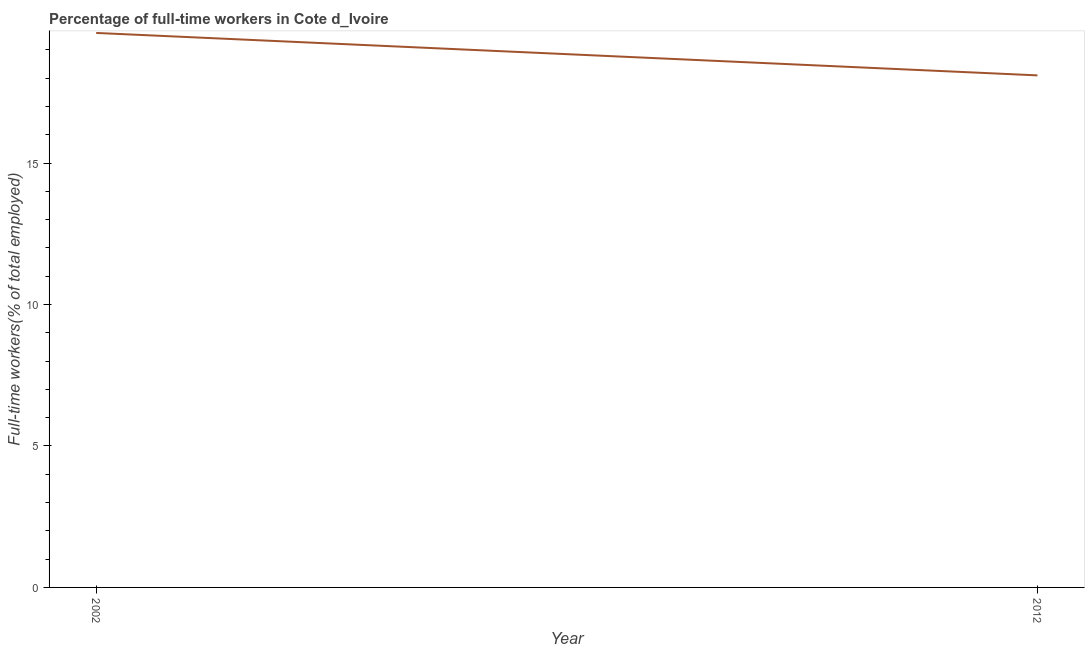What is the percentage of full-time workers in 2012?
Ensure brevity in your answer.  18.1. Across all years, what is the maximum percentage of full-time workers?
Offer a very short reply. 19.6. Across all years, what is the minimum percentage of full-time workers?
Make the answer very short. 18.1. What is the sum of the percentage of full-time workers?
Offer a very short reply. 37.7. What is the average percentage of full-time workers per year?
Provide a short and direct response. 18.85. What is the median percentage of full-time workers?
Provide a succinct answer. 18.85. In how many years, is the percentage of full-time workers greater than 3 %?
Give a very brief answer. 2. What is the ratio of the percentage of full-time workers in 2002 to that in 2012?
Give a very brief answer. 1.08. Is the percentage of full-time workers in 2002 less than that in 2012?
Your answer should be compact. No. How many years are there in the graph?
Keep it short and to the point. 2. Are the values on the major ticks of Y-axis written in scientific E-notation?
Your response must be concise. No. Does the graph contain any zero values?
Give a very brief answer. No. Does the graph contain grids?
Keep it short and to the point. No. What is the title of the graph?
Offer a very short reply. Percentage of full-time workers in Cote d_Ivoire. What is the label or title of the Y-axis?
Ensure brevity in your answer.  Full-time workers(% of total employed). What is the Full-time workers(% of total employed) in 2002?
Give a very brief answer. 19.6. What is the Full-time workers(% of total employed) in 2012?
Make the answer very short. 18.1. What is the ratio of the Full-time workers(% of total employed) in 2002 to that in 2012?
Keep it short and to the point. 1.08. 